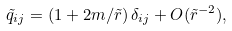<formula> <loc_0><loc_0><loc_500><loc_500>\tilde { q } _ { i j } = \left ( 1 + 2 m / \tilde { r } \right ) \delta _ { i j } + O ( \tilde { r } ^ { - 2 } ) ,</formula> 